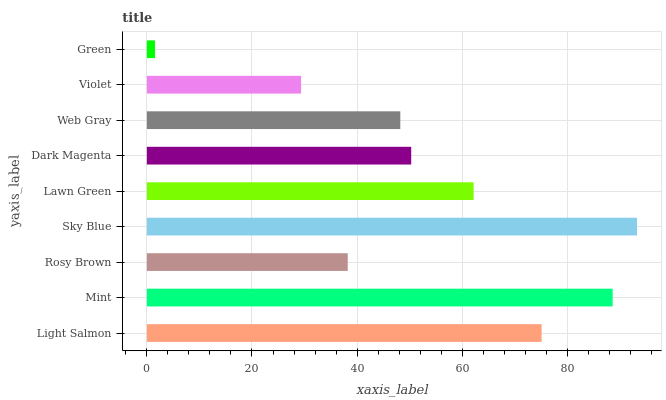Is Green the minimum?
Answer yes or no. Yes. Is Sky Blue the maximum?
Answer yes or no. Yes. Is Mint the minimum?
Answer yes or no. No. Is Mint the maximum?
Answer yes or no. No. Is Mint greater than Light Salmon?
Answer yes or no. Yes. Is Light Salmon less than Mint?
Answer yes or no. Yes. Is Light Salmon greater than Mint?
Answer yes or no. No. Is Mint less than Light Salmon?
Answer yes or no. No. Is Dark Magenta the high median?
Answer yes or no. Yes. Is Dark Magenta the low median?
Answer yes or no. Yes. Is Web Gray the high median?
Answer yes or no. No. Is Mint the low median?
Answer yes or no. No. 